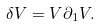Convert formula to latex. <formula><loc_0><loc_0><loc_500><loc_500>\delta V = V \partial _ { 1 } V .</formula> 